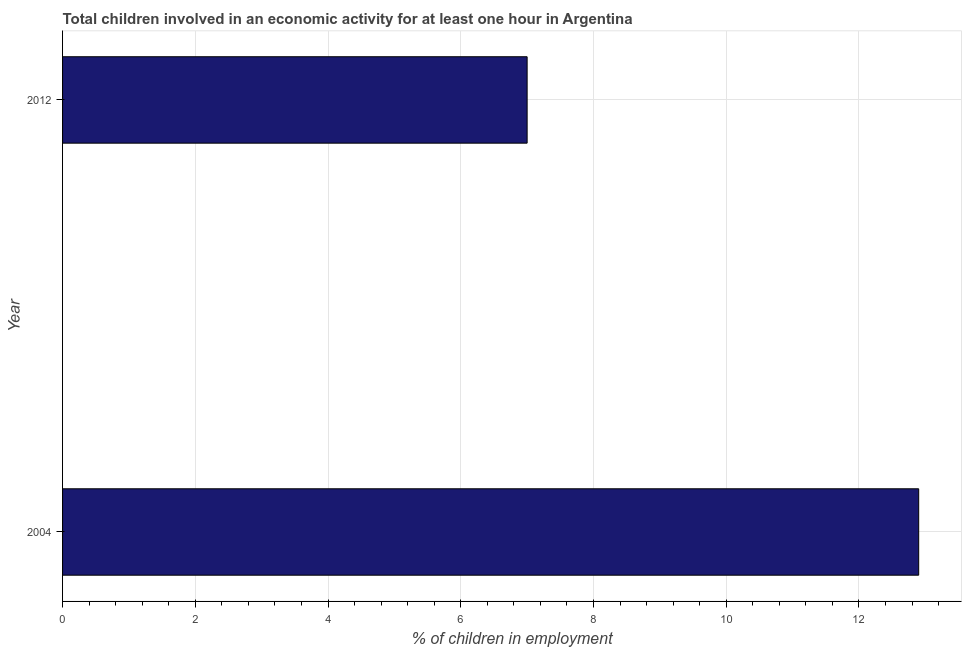Does the graph contain any zero values?
Provide a succinct answer. No. Does the graph contain grids?
Your answer should be very brief. Yes. What is the title of the graph?
Give a very brief answer. Total children involved in an economic activity for at least one hour in Argentina. What is the label or title of the X-axis?
Ensure brevity in your answer.  % of children in employment. What is the label or title of the Y-axis?
Give a very brief answer. Year. Across all years, what is the maximum percentage of children in employment?
Offer a terse response. 12.9. What is the sum of the percentage of children in employment?
Make the answer very short. 19.9. What is the average percentage of children in employment per year?
Provide a succinct answer. 9.95. What is the median percentage of children in employment?
Your answer should be compact. 9.95. What is the ratio of the percentage of children in employment in 2004 to that in 2012?
Your response must be concise. 1.84. Is the percentage of children in employment in 2004 less than that in 2012?
Make the answer very short. No. In how many years, is the percentage of children in employment greater than the average percentage of children in employment taken over all years?
Your answer should be very brief. 1. Are all the bars in the graph horizontal?
Your answer should be very brief. Yes. What is the % of children in employment in 2012?
Make the answer very short. 7. What is the difference between the % of children in employment in 2004 and 2012?
Your response must be concise. 5.9. What is the ratio of the % of children in employment in 2004 to that in 2012?
Your answer should be compact. 1.84. 